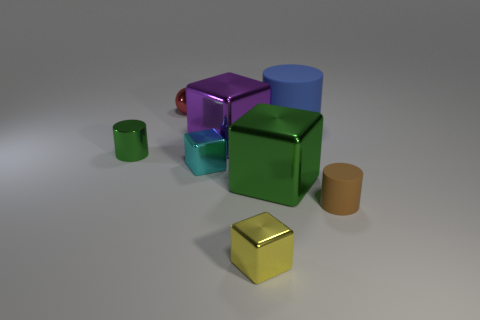Add 1 large blue matte things. How many objects exist? 9 Subtract all balls. How many objects are left? 7 Subtract 0 gray balls. How many objects are left? 8 Subtract all blue matte cylinders. Subtract all tiny yellow metallic blocks. How many objects are left? 6 Add 4 tiny things. How many tiny things are left? 9 Add 1 blue matte cylinders. How many blue matte cylinders exist? 2 